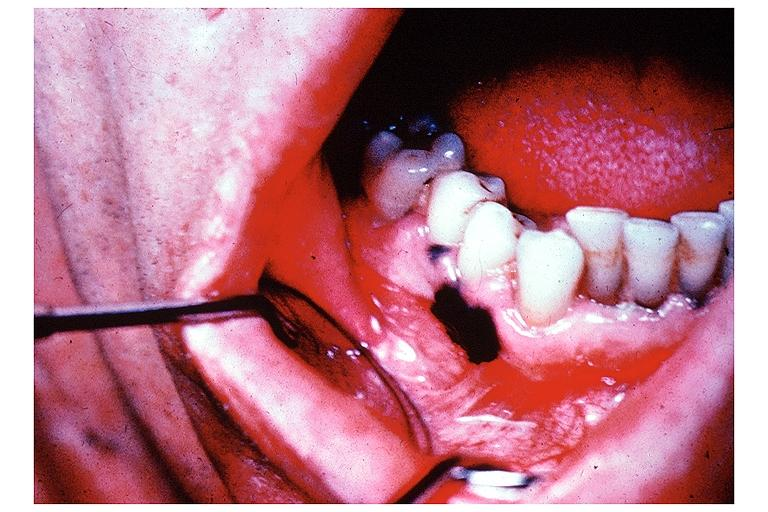what is present?
Answer the question using a single word or phrase. Oral 